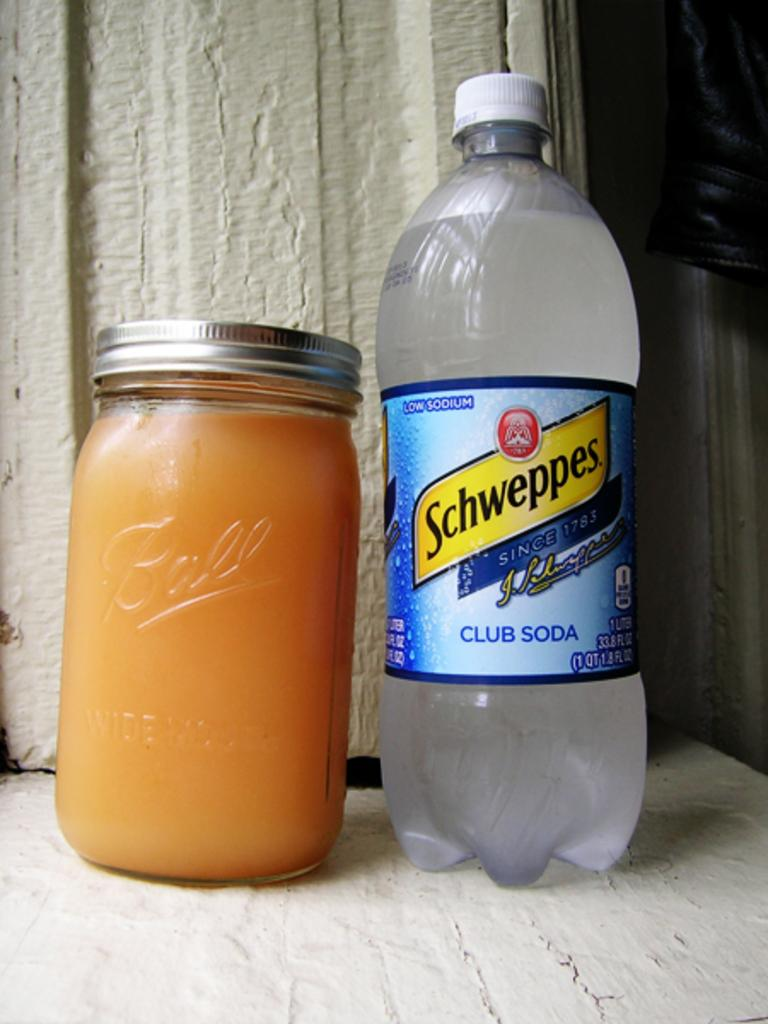Provide a one-sentence caption for the provided image. Certain brands of club soda have been in business and quenching thirsts since 1783. 